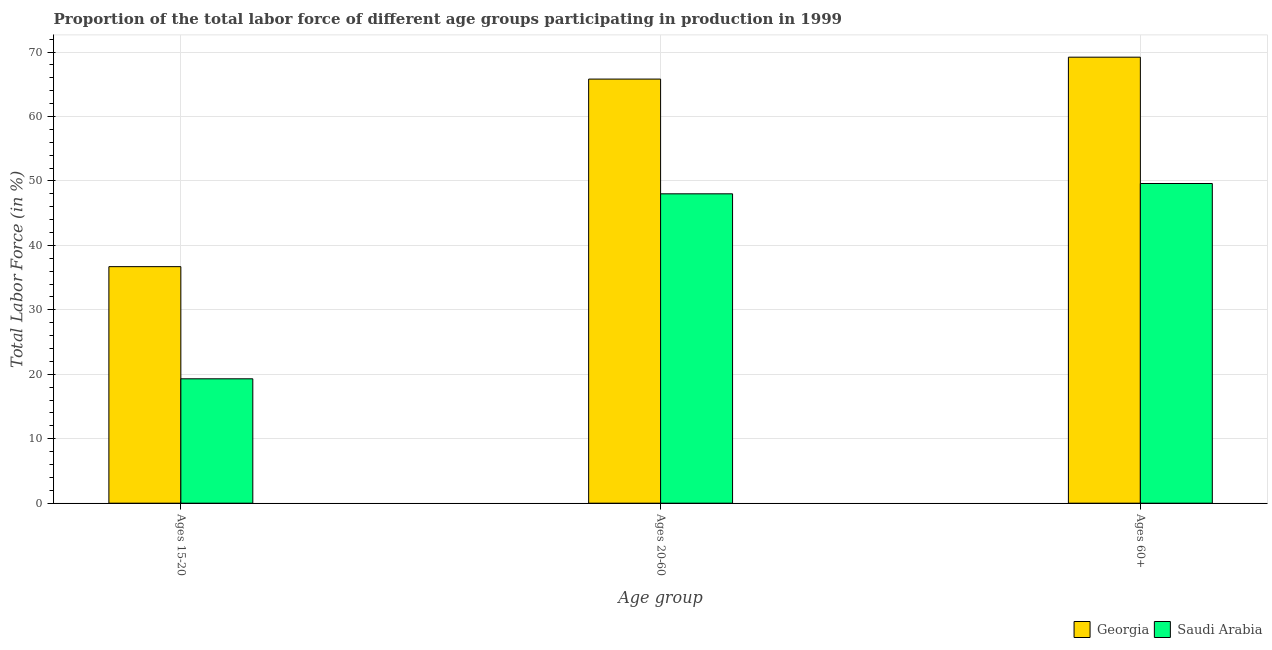Are the number of bars per tick equal to the number of legend labels?
Make the answer very short. Yes. Are the number of bars on each tick of the X-axis equal?
Your answer should be very brief. Yes. What is the label of the 3rd group of bars from the left?
Ensure brevity in your answer.  Ages 60+. What is the percentage of labor force within the age group 15-20 in Georgia?
Offer a very short reply. 36.7. Across all countries, what is the maximum percentage of labor force above age 60?
Give a very brief answer. 69.2. Across all countries, what is the minimum percentage of labor force within the age group 20-60?
Provide a succinct answer. 48. In which country was the percentage of labor force above age 60 maximum?
Your answer should be compact. Georgia. In which country was the percentage of labor force within the age group 20-60 minimum?
Your answer should be compact. Saudi Arabia. What is the total percentage of labor force within the age group 20-60 in the graph?
Provide a short and direct response. 113.8. What is the difference between the percentage of labor force within the age group 20-60 in Saudi Arabia and that in Georgia?
Give a very brief answer. -17.8. What is the difference between the percentage of labor force above age 60 in Saudi Arabia and the percentage of labor force within the age group 15-20 in Georgia?
Offer a very short reply. 12.9. What is the average percentage of labor force within the age group 20-60 per country?
Your response must be concise. 56.9. What is the difference between the percentage of labor force above age 60 and percentage of labor force within the age group 20-60 in Georgia?
Your response must be concise. 3.4. What is the ratio of the percentage of labor force above age 60 in Saudi Arabia to that in Georgia?
Your answer should be very brief. 0.72. Is the difference between the percentage of labor force within the age group 20-60 in Saudi Arabia and Georgia greater than the difference between the percentage of labor force above age 60 in Saudi Arabia and Georgia?
Make the answer very short. Yes. What is the difference between the highest and the second highest percentage of labor force within the age group 20-60?
Ensure brevity in your answer.  17.8. What is the difference between the highest and the lowest percentage of labor force within the age group 15-20?
Your answer should be very brief. 17.4. In how many countries, is the percentage of labor force above age 60 greater than the average percentage of labor force above age 60 taken over all countries?
Offer a very short reply. 1. What does the 1st bar from the left in Ages 60+ represents?
Keep it short and to the point. Georgia. What does the 1st bar from the right in Ages 60+ represents?
Keep it short and to the point. Saudi Arabia. How many bars are there?
Your response must be concise. 6. Does the graph contain any zero values?
Make the answer very short. No. How many legend labels are there?
Your answer should be very brief. 2. What is the title of the graph?
Your answer should be very brief. Proportion of the total labor force of different age groups participating in production in 1999. What is the label or title of the X-axis?
Your response must be concise. Age group. What is the label or title of the Y-axis?
Offer a very short reply. Total Labor Force (in %). What is the Total Labor Force (in %) in Georgia in Ages 15-20?
Offer a terse response. 36.7. What is the Total Labor Force (in %) in Saudi Arabia in Ages 15-20?
Provide a short and direct response. 19.3. What is the Total Labor Force (in %) of Georgia in Ages 20-60?
Make the answer very short. 65.8. What is the Total Labor Force (in %) in Saudi Arabia in Ages 20-60?
Provide a short and direct response. 48. What is the Total Labor Force (in %) of Georgia in Ages 60+?
Your response must be concise. 69.2. What is the Total Labor Force (in %) in Saudi Arabia in Ages 60+?
Your answer should be compact. 49.6. Across all Age group, what is the maximum Total Labor Force (in %) of Georgia?
Provide a succinct answer. 69.2. Across all Age group, what is the maximum Total Labor Force (in %) of Saudi Arabia?
Your answer should be very brief. 49.6. Across all Age group, what is the minimum Total Labor Force (in %) of Georgia?
Offer a very short reply. 36.7. Across all Age group, what is the minimum Total Labor Force (in %) in Saudi Arabia?
Give a very brief answer. 19.3. What is the total Total Labor Force (in %) in Georgia in the graph?
Give a very brief answer. 171.7. What is the total Total Labor Force (in %) of Saudi Arabia in the graph?
Your response must be concise. 116.9. What is the difference between the Total Labor Force (in %) in Georgia in Ages 15-20 and that in Ages 20-60?
Give a very brief answer. -29.1. What is the difference between the Total Labor Force (in %) in Saudi Arabia in Ages 15-20 and that in Ages 20-60?
Your response must be concise. -28.7. What is the difference between the Total Labor Force (in %) in Georgia in Ages 15-20 and that in Ages 60+?
Your answer should be very brief. -32.5. What is the difference between the Total Labor Force (in %) of Saudi Arabia in Ages 15-20 and that in Ages 60+?
Keep it short and to the point. -30.3. What is the difference between the Total Labor Force (in %) in Georgia in Ages 20-60 and that in Ages 60+?
Provide a succinct answer. -3.4. What is the difference between the Total Labor Force (in %) of Saudi Arabia in Ages 20-60 and that in Ages 60+?
Keep it short and to the point. -1.6. What is the difference between the Total Labor Force (in %) in Georgia in Ages 15-20 and the Total Labor Force (in %) in Saudi Arabia in Ages 20-60?
Offer a terse response. -11.3. What is the average Total Labor Force (in %) in Georgia per Age group?
Keep it short and to the point. 57.23. What is the average Total Labor Force (in %) in Saudi Arabia per Age group?
Make the answer very short. 38.97. What is the difference between the Total Labor Force (in %) in Georgia and Total Labor Force (in %) in Saudi Arabia in Ages 15-20?
Offer a very short reply. 17.4. What is the difference between the Total Labor Force (in %) of Georgia and Total Labor Force (in %) of Saudi Arabia in Ages 60+?
Offer a very short reply. 19.6. What is the ratio of the Total Labor Force (in %) in Georgia in Ages 15-20 to that in Ages 20-60?
Keep it short and to the point. 0.56. What is the ratio of the Total Labor Force (in %) in Saudi Arabia in Ages 15-20 to that in Ages 20-60?
Make the answer very short. 0.4. What is the ratio of the Total Labor Force (in %) of Georgia in Ages 15-20 to that in Ages 60+?
Provide a short and direct response. 0.53. What is the ratio of the Total Labor Force (in %) of Saudi Arabia in Ages 15-20 to that in Ages 60+?
Your response must be concise. 0.39. What is the ratio of the Total Labor Force (in %) in Georgia in Ages 20-60 to that in Ages 60+?
Ensure brevity in your answer.  0.95. What is the ratio of the Total Labor Force (in %) of Saudi Arabia in Ages 20-60 to that in Ages 60+?
Your answer should be compact. 0.97. What is the difference between the highest and the second highest Total Labor Force (in %) in Georgia?
Offer a terse response. 3.4. What is the difference between the highest and the lowest Total Labor Force (in %) of Georgia?
Give a very brief answer. 32.5. What is the difference between the highest and the lowest Total Labor Force (in %) of Saudi Arabia?
Offer a terse response. 30.3. 